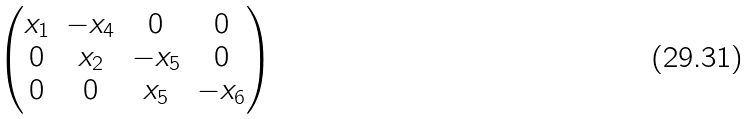Convert formula to latex. <formula><loc_0><loc_0><loc_500><loc_500>\begin{pmatrix} x _ { 1 } & - x _ { 4 } & 0 & 0 \\ 0 & x _ { 2 } & - x _ { 5 } & 0 \\ 0 & 0 & x _ { 5 } & - x _ { 6 } \end{pmatrix}</formula> 